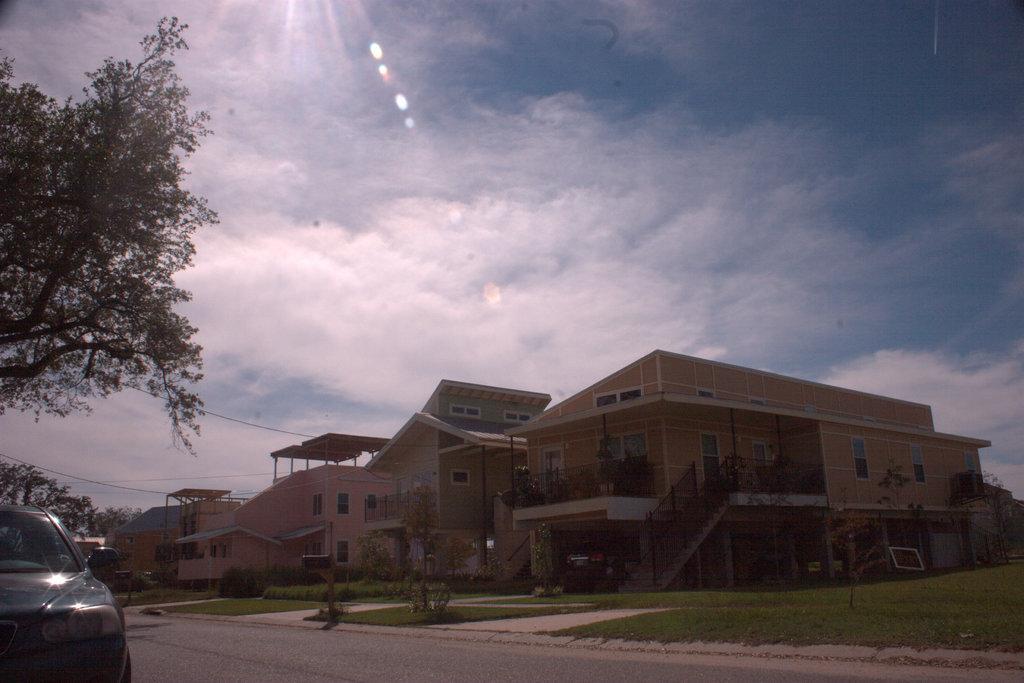Describe this image in one or two sentences. In this image we can see buildings, staircase, railings, metal rods, trees, bushes, houseplants, motor vehicle on the road, cables and sky with clouds. 